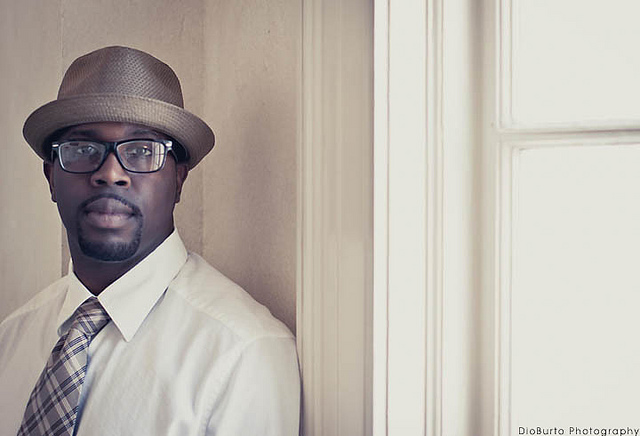Please transcribe the text in this image. DloBurto Photography 